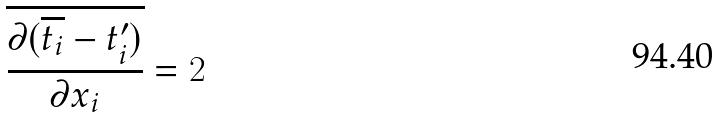Convert formula to latex. <formula><loc_0><loc_0><loc_500><loc_500>\overline { \frac { \partial ( \overline { t _ { i } } - t _ { i } ^ { \prime } ) } { \partial x _ { i } } } = 2</formula> 